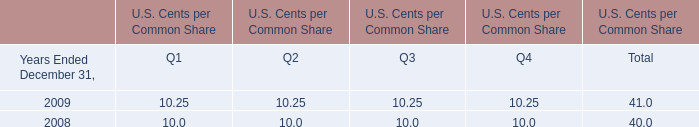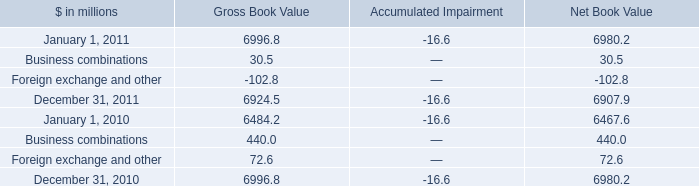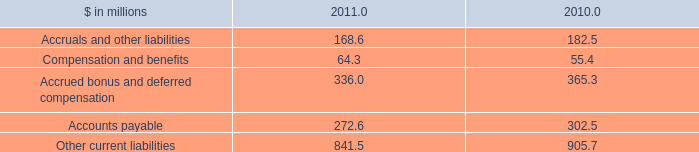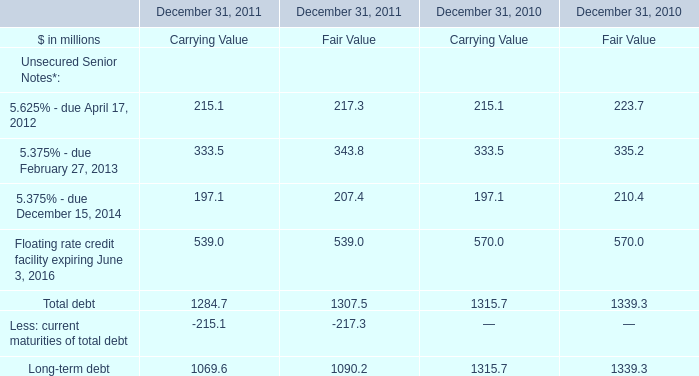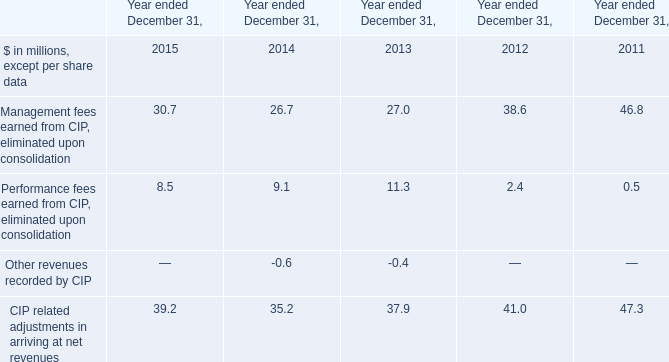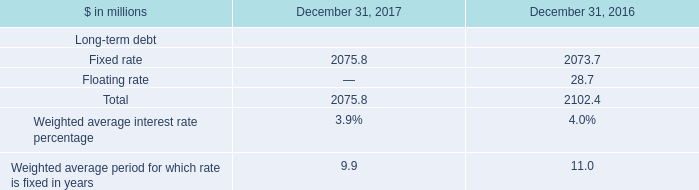Which year is the Gross Book Value in terms of Business combinations less? 
Answer: 2011. 